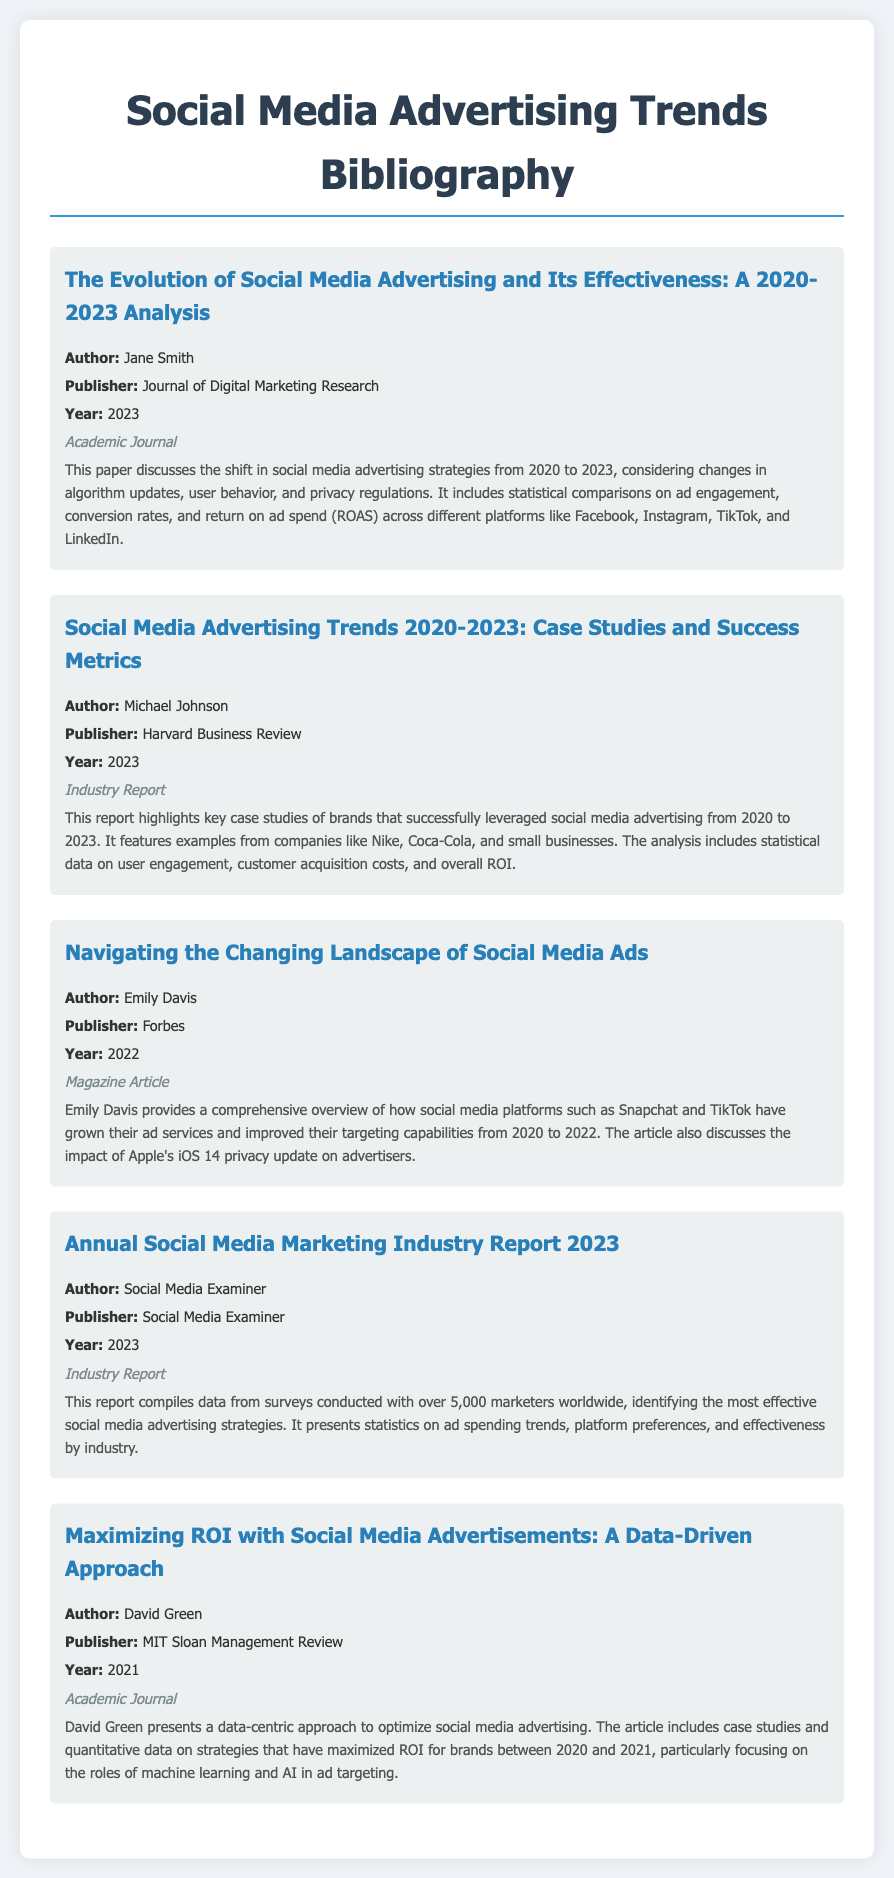What is the title of the first entry? The title of the first entry is provided in the document under the heading of the entry.
Answer: The Evolution of Social Media Advertising and Its Effectiveness: A 2020-2023 Analysis Who is the author of the second entry? The document lists the author of each entry under the author section for every case.
Answer: Michael Johnson What year was the fourth entry published? The publication year is specified in the document for each entry.
Answer: 2023 What does the summary of the last entry emphasize? The summary of each entry talks about the focal points of the research, which is highlighted in their respective summaries.
Answer: A data-driven approach Which publication featured the article by Emily Davis? The publication name is included in each entry, indicating where the article was published.
Answer: Forbes How many marketers were surveyed in the Annual Social Media Marketing Industry Report 2023? The statistics regarding the survey size are mentioned in the summary of the respective entry.
Answer: 5,000 What is the overarching theme of the document? The overall theme can be inferred from each entry revolving around social media advertising trends and effectiveness.
Answer: Social media advertising trends How are case studies utilized in the document? The summaries indicate how case studies are integrated into the discussions of effectiveness and strategies.
Answer: They highlight successful brands 